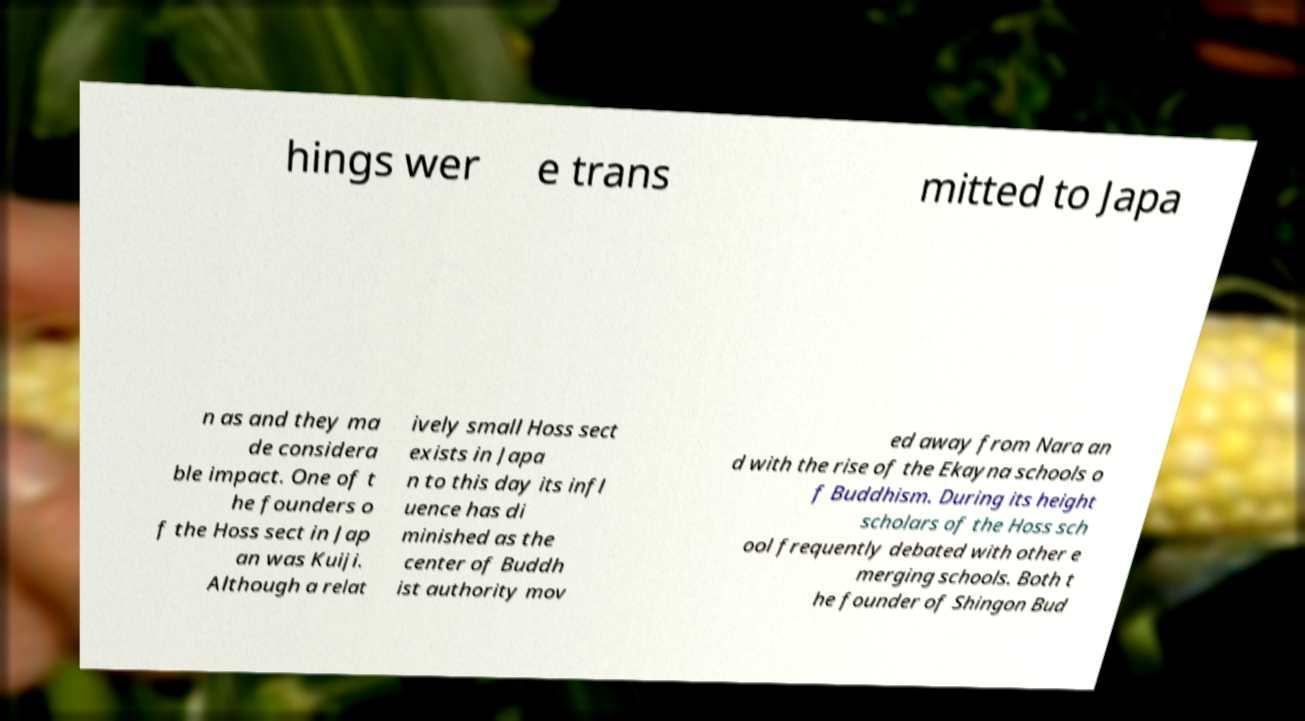Can you read and provide the text displayed in the image?This photo seems to have some interesting text. Can you extract and type it out for me? hings wer e trans mitted to Japa n as and they ma de considera ble impact. One of t he founders o f the Hoss sect in Jap an was Kuiji. Although a relat ively small Hoss sect exists in Japa n to this day its infl uence has di minished as the center of Buddh ist authority mov ed away from Nara an d with the rise of the Ekayna schools o f Buddhism. During its height scholars of the Hoss sch ool frequently debated with other e merging schools. Both t he founder of Shingon Bud 